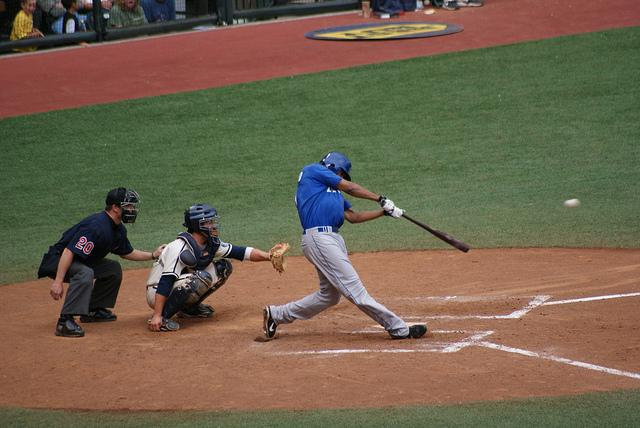What is the gear called that the umpire is wearing on his face? Please explain your reasoning. umpire mask. The man is wearing the mask to protect himself. 